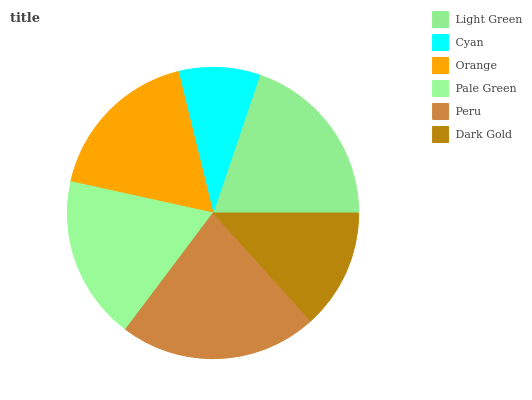Is Cyan the minimum?
Answer yes or no. Yes. Is Peru the maximum?
Answer yes or no. Yes. Is Orange the minimum?
Answer yes or no. No. Is Orange the maximum?
Answer yes or no. No. Is Orange greater than Cyan?
Answer yes or no. Yes. Is Cyan less than Orange?
Answer yes or no. Yes. Is Cyan greater than Orange?
Answer yes or no. No. Is Orange less than Cyan?
Answer yes or no. No. Is Pale Green the high median?
Answer yes or no. Yes. Is Orange the low median?
Answer yes or no. Yes. Is Cyan the high median?
Answer yes or no. No. Is Dark Gold the low median?
Answer yes or no. No. 